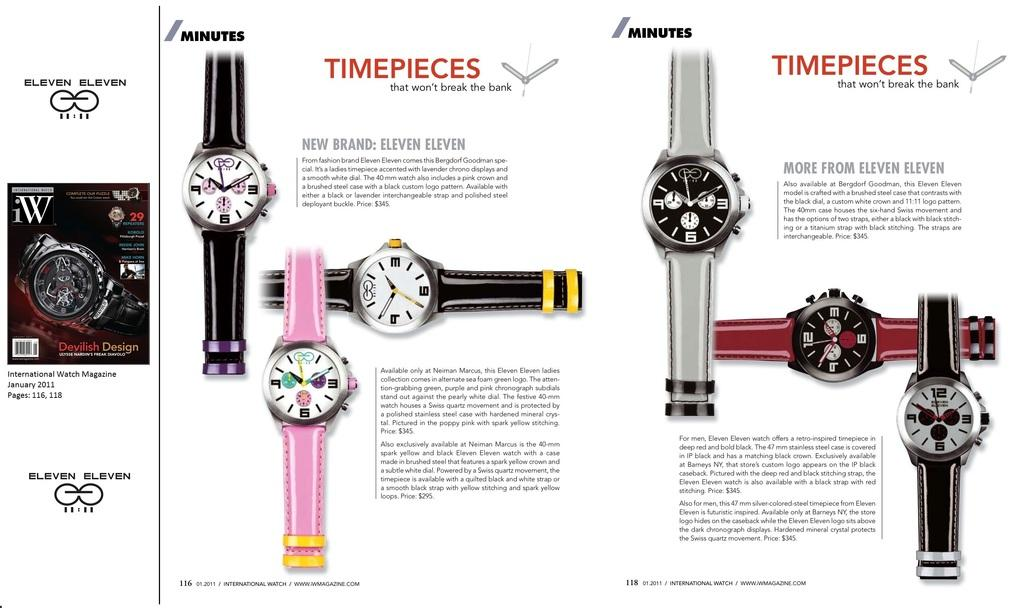<image>
Create a compact narrative representing the image presented. Page from a magazine which says "Timepieces" in red. 